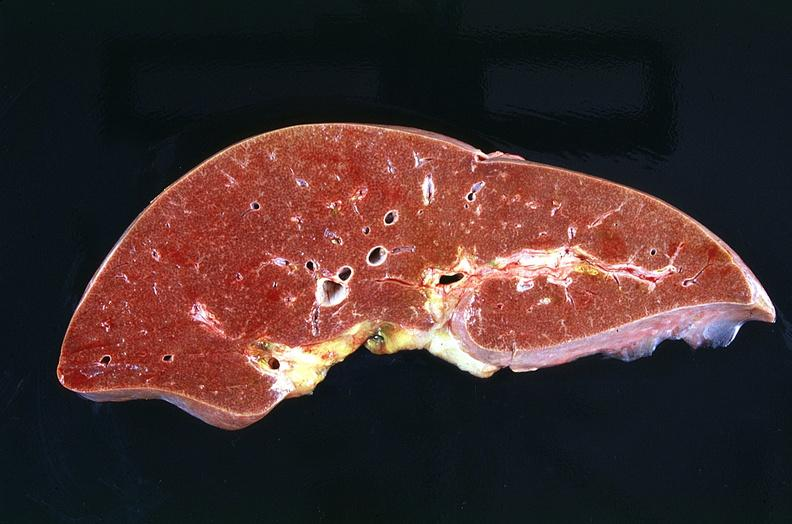does appendix show liver, congestion and mild micronodular cirrhosis heart failure cirrhosis?
Answer the question using a single word or phrase. No 